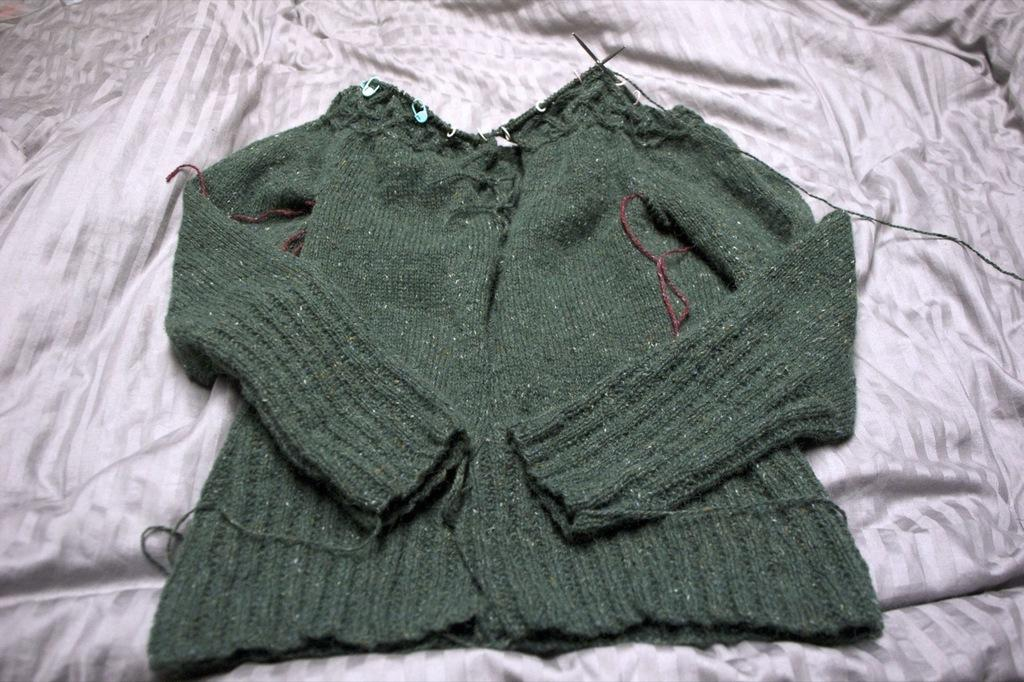What type of clothing item is in the image? There is a sweater in the image. On what is the sweater placed? The sweater is on a white color blanket. Can you tell me how many balls are visible on the sweater in the image? There are no balls visible on the sweater in the image. Is there a receipt included with the sweater in the image? There is no mention of a receipt in the image, and it is not visible. 